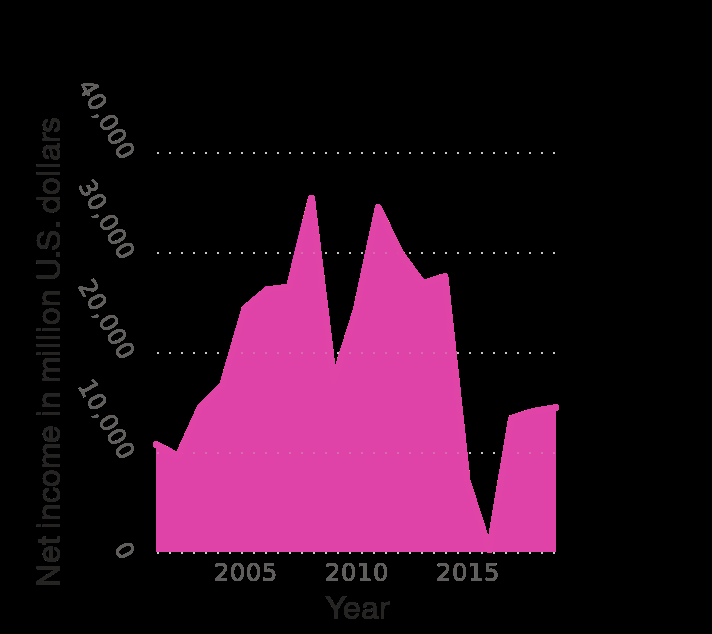<image>
please enumerates aspects of the construction of the chart Here a is a area diagram called Net income of ExxonMobil 's Upstream division from 2001 to 2019 (in million U.S. dollars). Net income in million U.S. dollars is measured along the y-axis. A linear scale of range 2005 to 2015 can be seen along the x-axis, labeled Year. Is there a line graph called Net income of ExxonMobil's Upstream division from 2005 to 2015 (in million U.S. dollars)? No.Here a is a area diagram called Net income of ExxonMobil 's Upstream division from 2001 to 2019 (in million U.S. dollars). Net income in million U.S. dollars is measured along the y-axis. A linear scale of range 2005 to 2015 can be seen along the x-axis, labeled Year. 